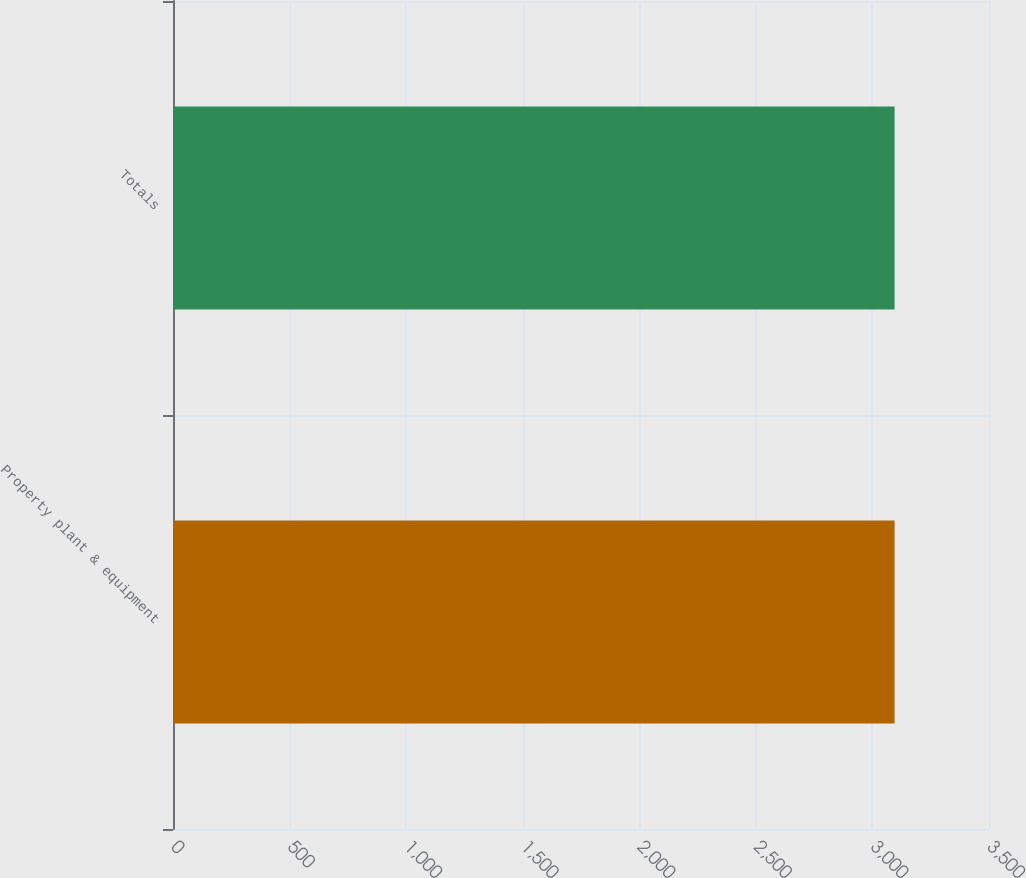<chart> <loc_0><loc_0><loc_500><loc_500><bar_chart><fcel>Property plant & equipment<fcel>Totals<nl><fcel>3095<fcel>3095.1<nl></chart> 